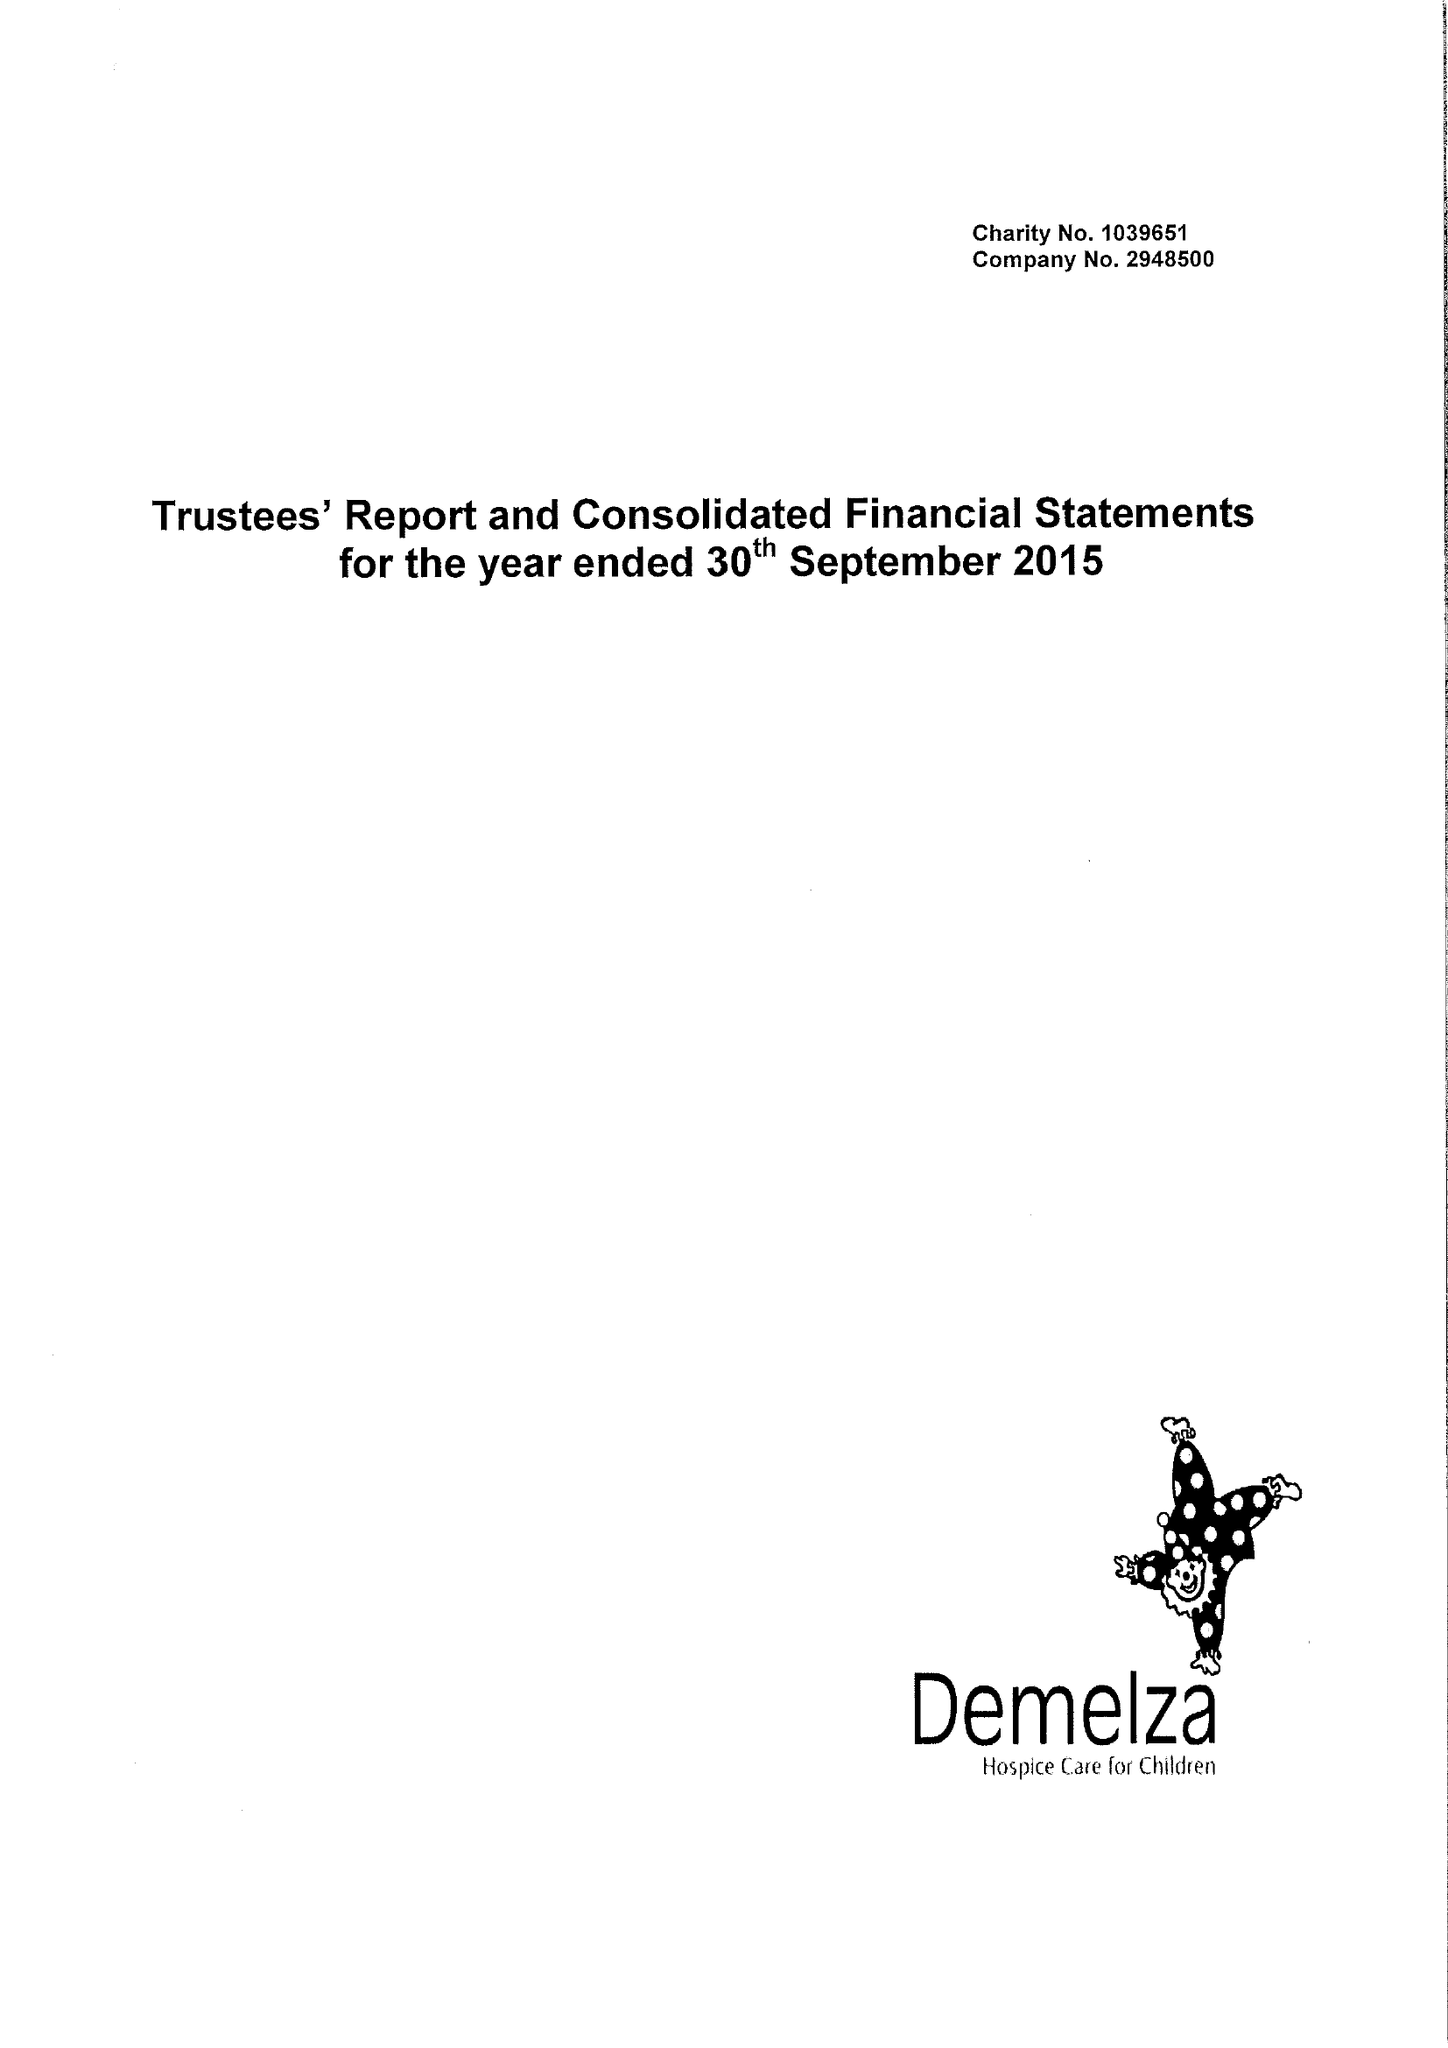What is the value for the address__street_line?
Answer the question using a single word or phrase. ROOK LANE 